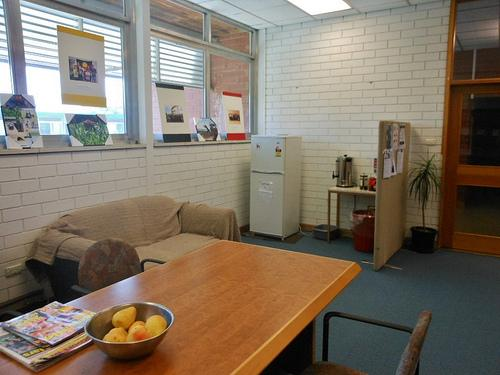Identify the primary piece of furniture present in the image and describe its color and placement. The primary piece of furniture is a brown sofa placed against a wall. How many refrigerators are there in the break room, and what size are they? There is one small white refrigerator in the break room. What type of container is the trash in and what color is it? The trash is in a red trash container with a clear trash bag. Enumerate the items found on the wooden table. A stack of papers, magazines, and a silver coffee pot are found on the wooden table. Provide a brief overview of the objects contained in the image. The image features a break room with a small white refrigerator, a brown sofa, a black pot plant, blinds on a window, magazines on a wooden table, silver coffee pot, red trash can, a long wooden table, a picture on a window ledge, and fruit in a metal bowl. How many types of fruit are in the bowl, and what color is the bowl? There is only one type of fruit (pears) in the bowl which is silver in color. Describe the window in the room, including its coverings. The window in the room has blinds on it and the blinds are open. What type of flooring is captured in the image? The floor is covered with blue carpet in the image. What kind of artwork is depicted in the image, and where is it showcased? A picture on white and yellow canvas is showcased on a windowsill. What type of plant is in the image and where is it located? A thin green house plant is located in a black pot in the corner of the room. Is the trash can under the table empty or filled with a trash bag? Filled with a clear trash bag. Choose the correct option: Is the refrigerator blue or white? White How does the room feel based on the current setup and objects present? The room feels cozy and inviting. Find the position and the size of the artwork on the windowsill. X:2 Y:90 Width:42 Height:42 Analyze the interaction between the brown sofa and the love seat. The brown sofa and love seat are both placed against the wall and provide seating options. What is the position of the small white refrigerator? X:247 Y:130 Width:53 Height:53 On the wooden table, there is a delicious chocolate cake waiting to be eaten. Don't let it go to waste! No, it's not mentioned in the image. Which objects are on the wooden table? A stack of papers, magazines, and a silver coffee pot. Point out the text present in the image, if any. No text present. List all objects positioned in the top-left corner of the image. A window, blinds on windows, artwork on a windowsill, and a picture on white and yellow canvas. What material is the coffee pot made of? Silver Rate the image quality on a scale of 1-10. 7 Identify and label the distinct areas of the image, such as objects, walls, and floors. Walls: white bricks, floor: blue carpet, objects: refrigerator, sofa, house plant, trash can, etc. Describe the attributes of the house plant in a corner of the room. Green plant in a black pot. Map the referential expression "pears in a stainless steel bowl" to its corresponding object. X:77 Y:295 Width:101 Height:101 Identify any unusual or unexpected elements in the image. A small white refrigerator in the brake room. What kind of furniture is placed against the wall? A brown sofa and a love seat. What type of fruit is in the metal bowl? Pears 